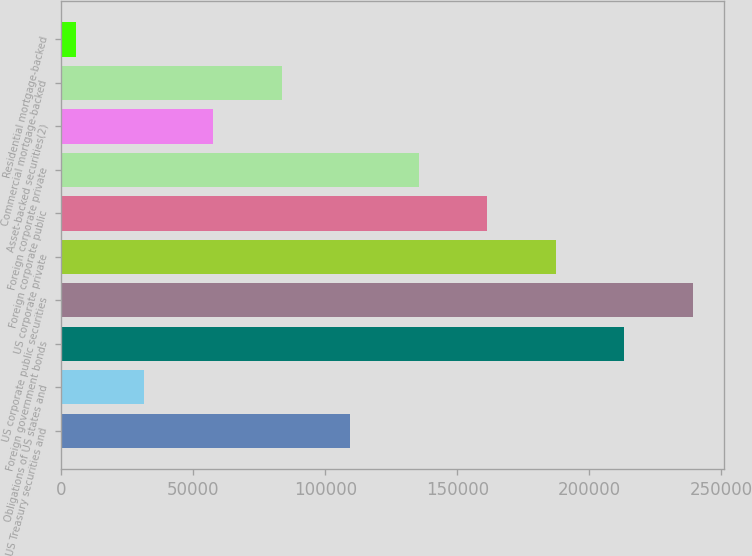<chart> <loc_0><loc_0><loc_500><loc_500><bar_chart><fcel>US Treasury securities and<fcel>Obligations of US states and<fcel>Foreign government bonds<fcel>US corporate public securities<fcel>US corporate private<fcel>Foreign corporate public<fcel>Foreign corporate private<fcel>Asset-backed securities(2)<fcel>Commercial mortgage-backed<fcel>Residential mortgage-backed<nl><fcel>109414<fcel>31562.4<fcel>213215<fcel>239166<fcel>187265<fcel>161314<fcel>135364<fcel>57512.8<fcel>83463.2<fcel>5612<nl></chart> 